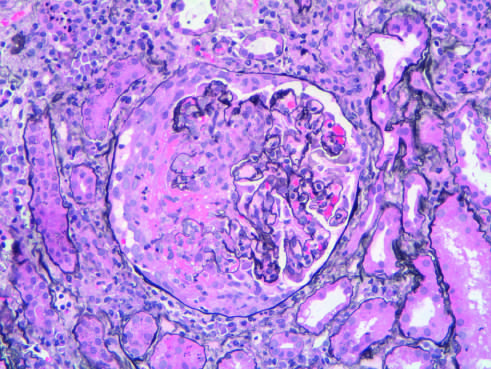what is typical of anca (anti-neutrophil cytoplasmic antibody)- associated crescentic glomerulonephritis?
Answer the question using a single word or phrase. The segmental distribution 